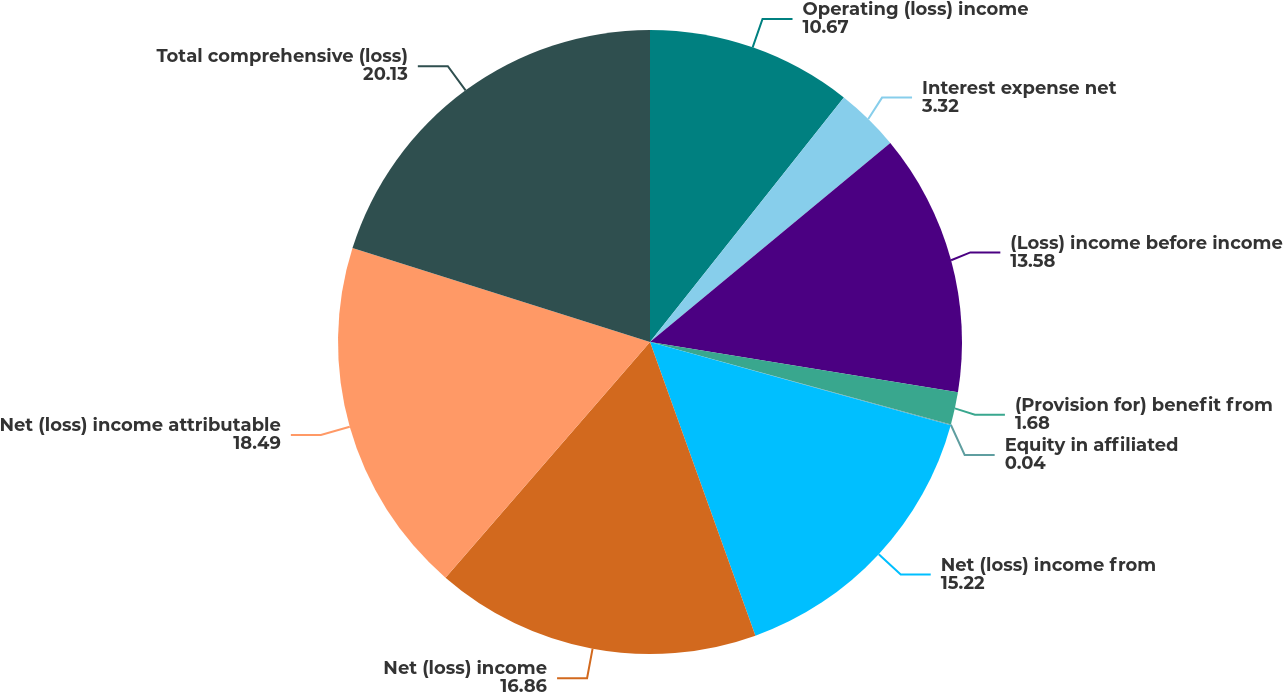Convert chart to OTSL. <chart><loc_0><loc_0><loc_500><loc_500><pie_chart><fcel>Operating (loss) income<fcel>Interest expense net<fcel>(Loss) income before income<fcel>(Provision for) benefit from<fcel>Equity in affiliated<fcel>Net (loss) income from<fcel>Net (loss) income<fcel>Net (loss) income attributable<fcel>Total comprehensive (loss)<nl><fcel>10.67%<fcel>3.32%<fcel>13.58%<fcel>1.68%<fcel>0.04%<fcel>15.22%<fcel>16.86%<fcel>18.49%<fcel>20.13%<nl></chart> 